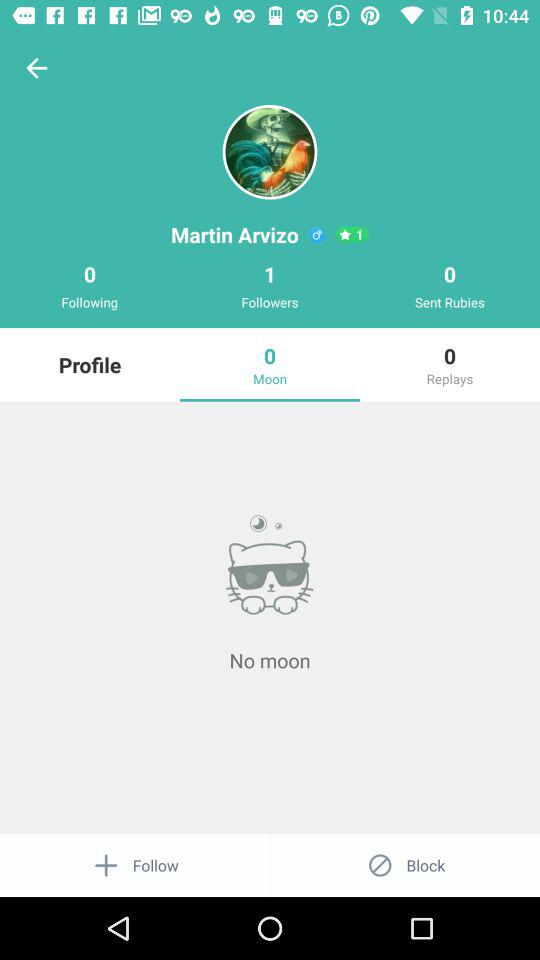How many more followers does Martin Arvizo have than sent rubies?
Answer the question using a single word or phrase. 1 